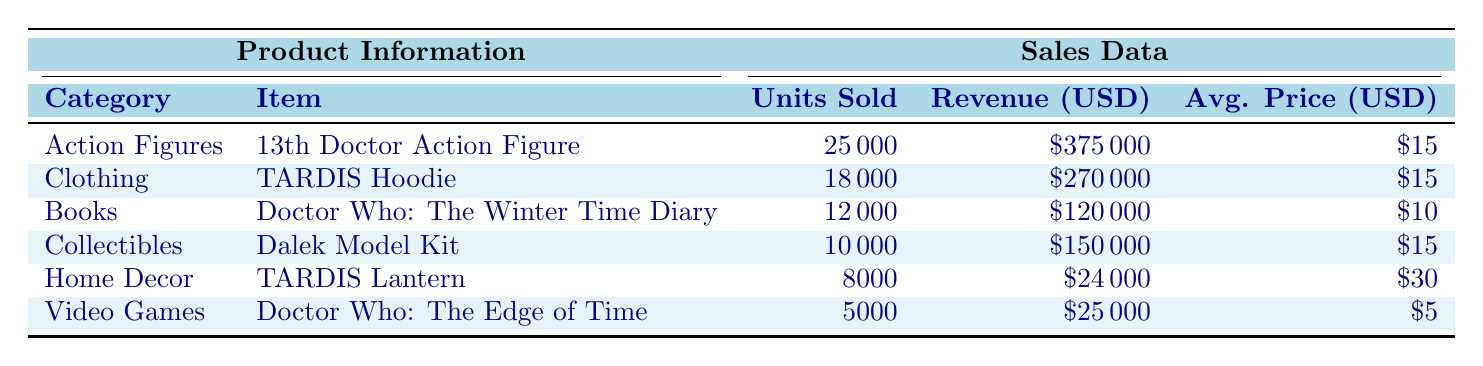What is the total revenue generated from the Action Figures category? From the table, the revenue for the Action Figures category is listed as 375000 USD. Since this is a direct retrieval of the information provided, we can confirm it straightforwardly.
Answer: 375000 USD Which item sold the most units in 2022? According to the table, the item with the highest number of units sold is the "13th Doctor Action Figure," with 25000 units sold. We can identify this by comparing the Units Sold column across all items.
Answer: 13th Doctor Action Figure Is the average price of the TARDIS Lantern higher than the average price of the Dalek Model Kit? The average price of the TARDIS Lantern is 30 USD, while the average price of the Dalek Model Kit is 15 USD. Since 30 is greater than 15, the average price of the TARDIS Lantern is indeed higher.
Answer: Yes What is the total number of units sold across all categories? To find the total units sold, add up all units from each category: 25000 + 18000 + 12000 + 10000 + 8000 + 5000 = 78000. This is a simple addition of all the units.
Answer: 78000 How much revenue was generated from video games? The revenue generated from the video games category, specifically for "Doctor Who: The Edge of Time," is listed as 25000 USD. This information can be directly pulled from the revenue column for that item.
Answer: 25000 USD Is the average price of books lower than the average price of clothing items? The average price for the books category is 10 USD, while the average price for clothing (TARDIS Hoodie) is 15 USD. Since 10 is less than 15, we can conclude that the average price of books is indeed lower than that of clothing.
Answer: Yes What is the difference in units sold between the TARDIS Hoodie and the TARDIS Lantern? To find the difference, subtract the units sold for the TARDIS Lantern (8000) from the units sold for the TARDIS Hoodie (18000): 18000 - 8000 = 10000. This is a straightforward subtraction operation.
Answer: 10000 What is the average revenue per unit sold for all items combined? First, we need to find the total revenue by adding up all the revenues: 375000 + 270000 + 120000 + 150000 + 24000 + 25000 = 990000. Then, we divide this by the total units sold, which is 78000: 990000 / 78000 ≈ 12.69. This requires both addition and division.
Answer: Approximately 12.69 USD How many items had an average price of 15 USD or more? The items with an average price of 15 USD or more are the "13th Doctor Action Figure," "TARDIS Hoodie," and "Dalek Model Kit." The TARDIS Lantern is 30 USD, and "Doctor Who: The Edge of Time" is 5 USD, which makes 4 items. We tally those that meet the criteria in the table.
Answer: 4 